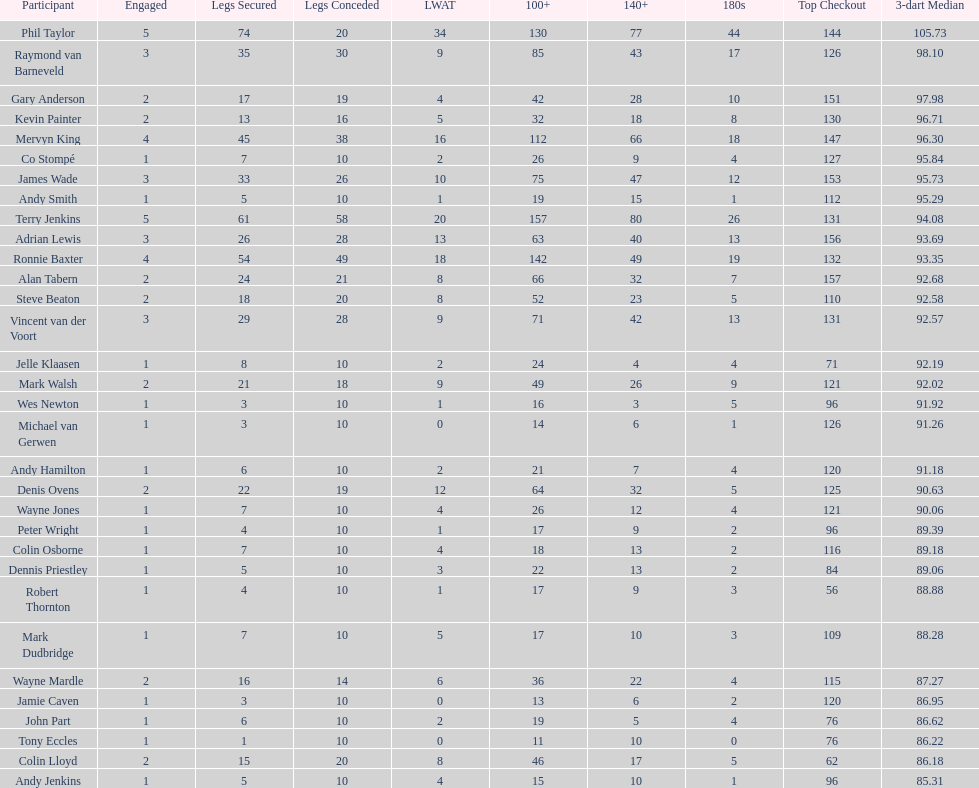Which player lost the least? Co Stompé, Andy Smith, Jelle Klaasen, Wes Newton, Michael van Gerwen, Andy Hamilton, Wayne Jones, Peter Wright, Colin Osborne, Dennis Priestley, Robert Thornton, Mark Dudbridge, Jamie Caven, John Part, Tony Eccles, Andy Jenkins. 